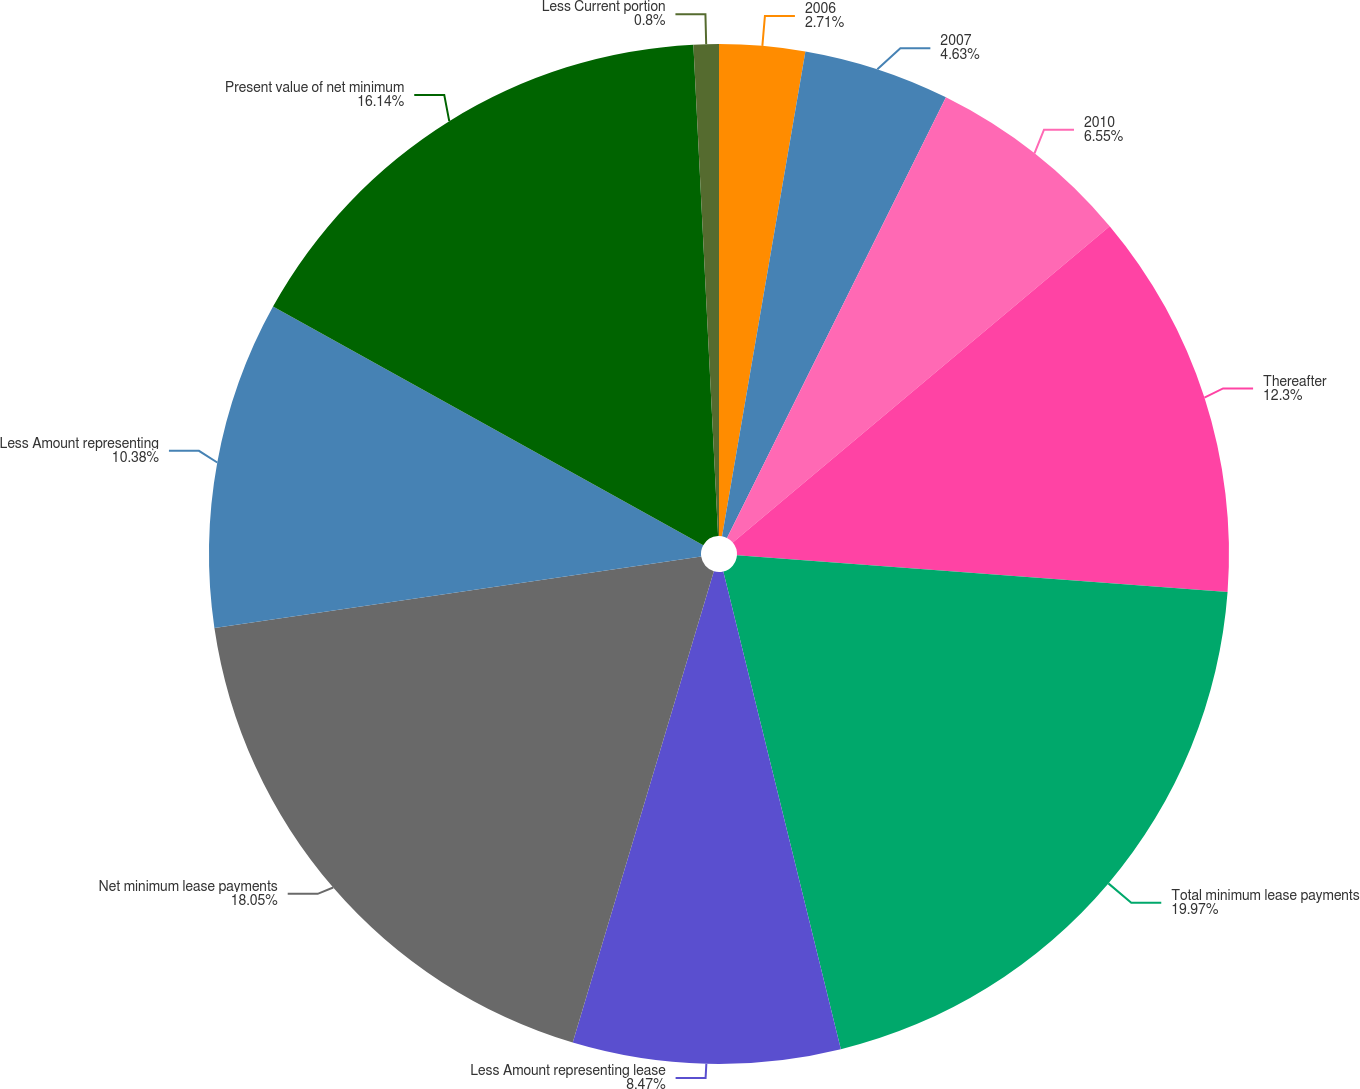Convert chart. <chart><loc_0><loc_0><loc_500><loc_500><pie_chart><fcel>2006<fcel>2007<fcel>2010<fcel>Thereafter<fcel>Total minimum lease payments<fcel>Less Amount representing lease<fcel>Net minimum lease payments<fcel>Less Amount representing<fcel>Present value of net minimum<fcel>Less Current portion<nl><fcel>2.71%<fcel>4.63%<fcel>6.55%<fcel>12.3%<fcel>19.97%<fcel>8.47%<fcel>18.05%<fcel>10.38%<fcel>16.14%<fcel>0.8%<nl></chart> 